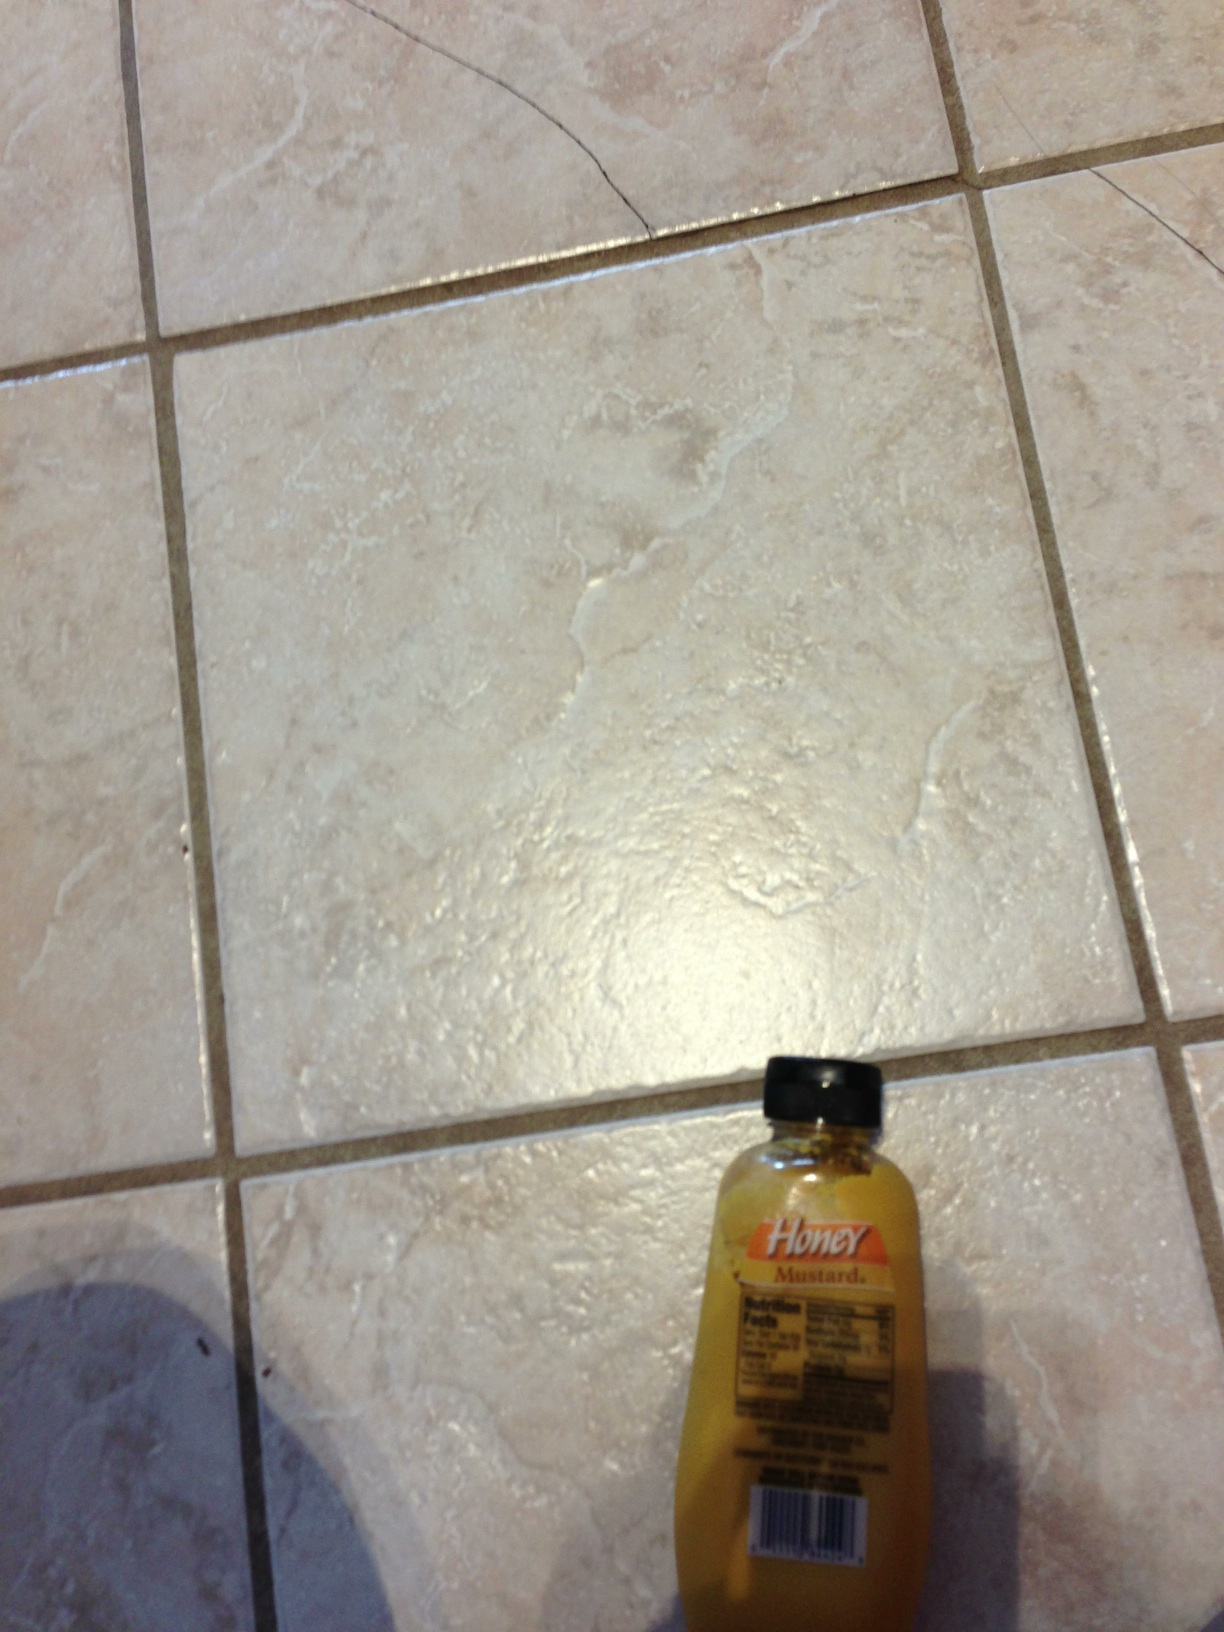Could you create a detailed recipe using honey mustard? Certainly! Here is a detailed recipe for Honey Mustard Chicken: 

**Ingredients:**

- 4 boneless, skinless chicken breasts
- 1/2 cup honey mustard salad dressing
- 2 tablespoons olive oil
- 2 cloves garlic, minced
- 1 tablespoon lemon juice
- Salt and pepper to taste
- Fresh parsley, chopped (optional)

**Instructions:**

1. Preheat your oven to 375°F (190°C).
2. In a bowl, combine the honey mustard salad dressing, olive oil, minced garlic, and lemon juice.
3. Season the chicken breasts with salt and pepper, then place them in a baking dish.
4. Pour the honey mustard mixture over the chicken breasts, ensuring they are well-coated.
5. Bake in the preheated oven for 25-30 minutes or until the chicken is cooked through and reaches an internal temperature of 165°F (75°C).
6. Garnish with fresh parsley if desired and serve with your favorite sides such as roasted vegetables, rice, or a fresh salad.

Enjoy your delicious Honey Mustard Chicken! 